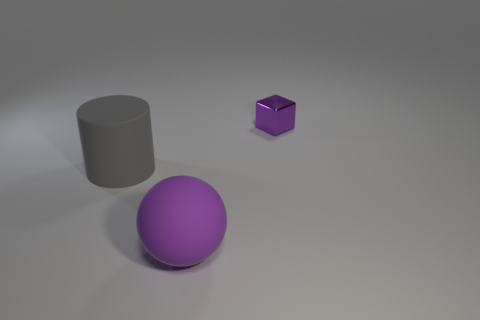Add 2 small objects. How many objects exist? 5 Subtract all cubes. How many objects are left? 2 Subtract 1 cylinders. How many cylinders are left? 0 Subtract all purple cylinders. Subtract all purple blocks. How many cylinders are left? 1 Subtract all large cylinders. Subtract all large gray cylinders. How many objects are left? 1 Add 3 matte cylinders. How many matte cylinders are left? 4 Add 1 small objects. How many small objects exist? 2 Subtract 0 cyan balls. How many objects are left? 3 